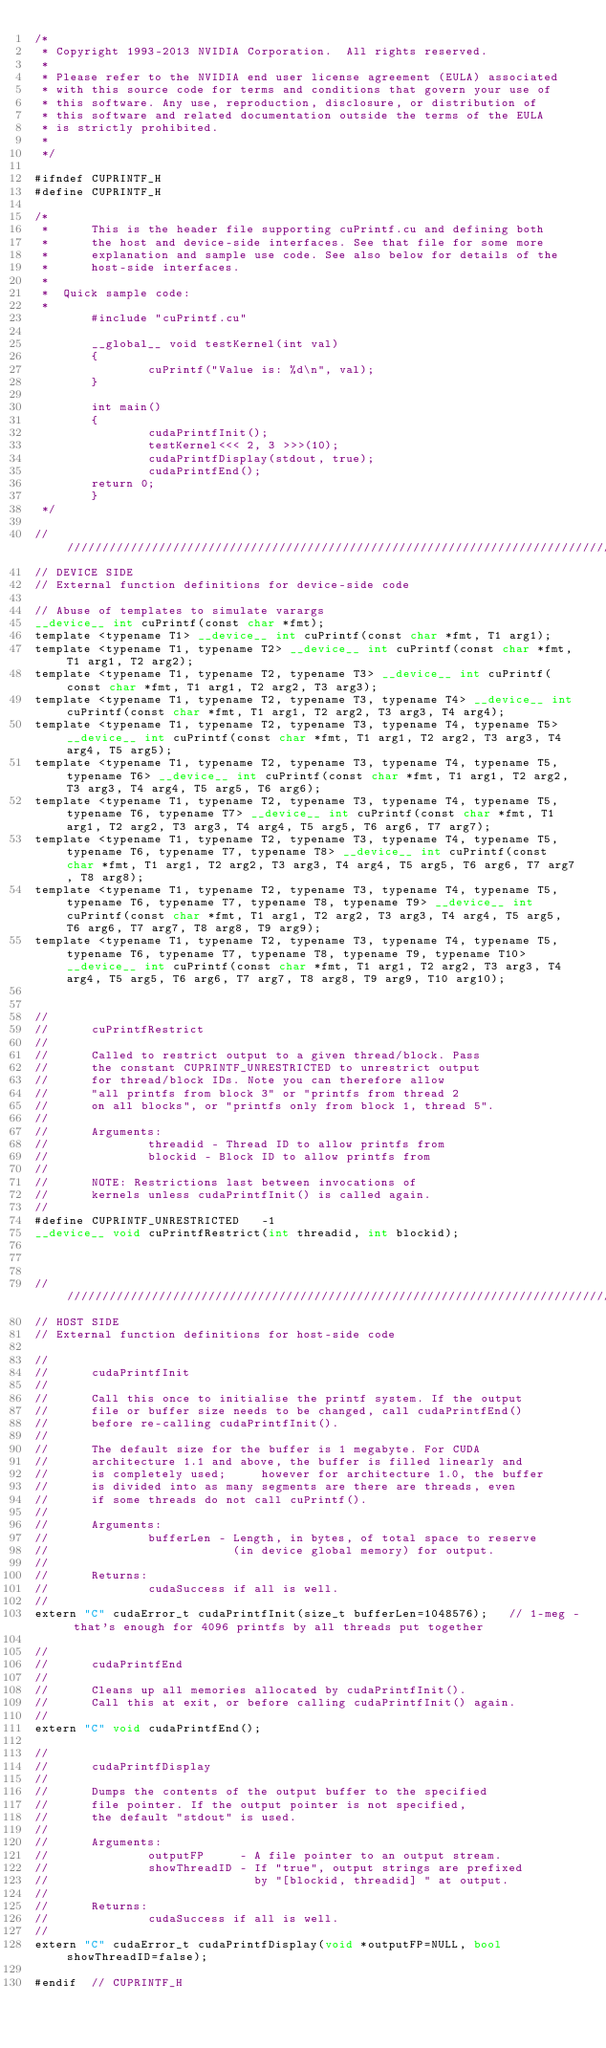Convert code to text. <code><loc_0><loc_0><loc_500><loc_500><_Cuda_>/*
 * Copyright 1993-2013 NVIDIA Corporation.  All rights reserved.
 *
 * Please refer to the NVIDIA end user license agreement (EULA) associated
 * with this source code for terms and conditions that govern your use of
 * this software. Any use, reproduction, disclosure, or distribution of
 * this software and related documentation outside the terms of the EULA
 * is strictly prohibited.
 *
 */

#ifndef CUPRINTF_H
#define CUPRINTF_H

/*
 *      This is the header file supporting cuPrintf.cu and defining both
 *      the host and device-side interfaces. See that file for some more
 *      explanation and sample use code. See also below for details of the
 *      host-side interfaces.
 *
 *  Quick sample code:
 *
        #include "cuPrintf.cu"

        __global__ void testKernel(int val)
        {
                cuPrintf("Value is: %d\n", val);
        }

        int main()
        {
                cudaPrintfInit();
                testKernel<<< 2, 3 >>>(10);
                cudaPrintfDisplay(stdout, true);
                cudaPrintfEnd();
        return 0;
        }
 */

///////////////////////////////////////////////////////////////////////////////
// DEVICE SIDE
// External function definitions for device-side code

// Abuse of templates to simulate varargs
__device__ int cuPrintf(const char *fmt);
template <typename T1> __device__ int cuPrintf(const char *fmt, T1 arg1);
template <typename T1, typename T2> __device__ int cuPrintf(const char *fmt, T1 arg1, T2 arg2);
template <typename T1, typename T2, typename T3> __device__ int cuPrintf(const char *fmt, T1 arg1, T2 arg2, T3 arg3);
template <typename T1, typename T2, typename T3, typename T4> __device__ int cuPrintf(const char *fmt, T1 arg1, T2 arg2, T3 arg3, T4 arg4);
template <typename T1, typename T2, typename T3, typename T4, typename T5> __device__ int cuPrintf(const char *fmt, T1 arg1, T2 arg2, T3 arg3, T4 arg4, T5 arg5);
template <typename T1, typename T2, typename T3, typename T4, typename T5, typename T6> __device__ int cuPrintf(const char *fmt, T1 arg1, T2 arg2, T3 arg3, T4 arg4, T5 arg5, T6 arg6);
template <typename T1, typename T2, typename T3, typename T4, typename T5, typename T6, typename T7> __device__ int cuPrintf(const char *fmt, T1 arg1, T2 arg2, T3 arg3, T4 arg4, T5 arg5, T6 arg6, T7 arg7);
template <typename T1, typename T2, typename T3, typename T4, typename T5, typename T6, typename T7, typename T8> __device__ int cuPrintf(const char *fmt, T1 arg1, T2 arg2, T3 arg3, T4 arg4, T5 arg5, T6 arg6, T7 arg7, T8 arg8);
template <typename T1, typename T2, typename T3, typename T4, typename T5, typename T6, typename T7, typename T8, typename T9> __device__ int cuPrintf(const char *fmt, T1 arg1, T2 arg2, T3 arg3, T4 arg4, T5 arg5, T6 arg6, T7 arg7, T8 arg8, T9 arg9);
template <typename T1, typename T2, typename T3, typename T4, typename T5, typename T6, typename T7, typename T8, typename T9, typename T10> __device__ int cuPrintf(const char *fmt, T1 arg1, T2 arg2, T3 arg3, T4 arg4, T5 arg5, T6 arg6, T7 arg7, T8 arg8, T9 arg9, T10 arg10);


//
//      cuPrintfRestrict
//
//      Called to restrict output to a given thread/block. Pass
//      the constant CUPRINTF_UNRESTRICTED to unrestrict output
//      for thread/block IDs. Note you can therefore allow
//      "all printfs from block 3" or "printfs from thread 2
//      on all blocks", or "printfs only from block 1, thread 5".
//
//      Arguments:
//              threadid - Thread ID to allow printfs from
//              blockid - Block ID to allow printfs from
//
//      NOTE: Restrictions last between invocations of
//      kernels unless cudaPrintfInit() is called again.
//
#define CUPRINTF_UNRESTRICTED   -1
__device__ void cuPrintfRestrict(int threadid, int blockid);



///////////////////////////////////////////////////////////////////////////////
// HOST SIDE
// External function definitions for host-side code

//
//      cudaPrintfInit
//
//      Call this once to initialise the printf system. If the output
//      file or buffer size needs to be changed, call cudaPrintfEnd()
//      before re-calling cudaPrintfInit().
//
//      The default size for the buffer is 1 megabyte. For CUDA
//      architecture 1.1 and above, the buffer is filled linearly and
//      is completely used;     however for architecture 1.0, the buffer
//      is divided into as many segments are there are threads, even
//      if some threads do not call cuPrintf().
//
//      Arguments:
//              bufferLen - Length, in bytes, of total space to reserve
//                          (in device global memory) for output.
//
//      Returns:
//              cudaSuccess if all is well.
//
extern "C" cudaError_t cudaPrintfInit(size_t bufferLen=1048576);   // 1-meg - that's enough for 4096 printfs by all threads put together

//
//      cudaPrintfEnd
//
//      Cleans up all memories allocated by cudaPrintfInit().
//      Call this at exit, or before calling cudaPrintfInit() again.
//
extern "C" void cudaPrintfEnd();

//
//      cudaPrintfDisplay
//
//      Dumps the contents of the output buffer to the specified
//      file pointer. If the output pointer is not specified,
//      the default "stdout" is used.
//
//      Arguments:
//              outputFP     - A file pointer to an output stream.
//              showThreadID - If "true", output strings are prefixed
//                             by "[blockid, threadid] " at output.
//
//      Returns:
//              cudaSuccess if all is well.
//
extern "C" cudaError_t cudaPrintfDisplay(void *outputFP=NULL, bool showThreadID=false);

#endif  // CUPRINTF_H
</code> 